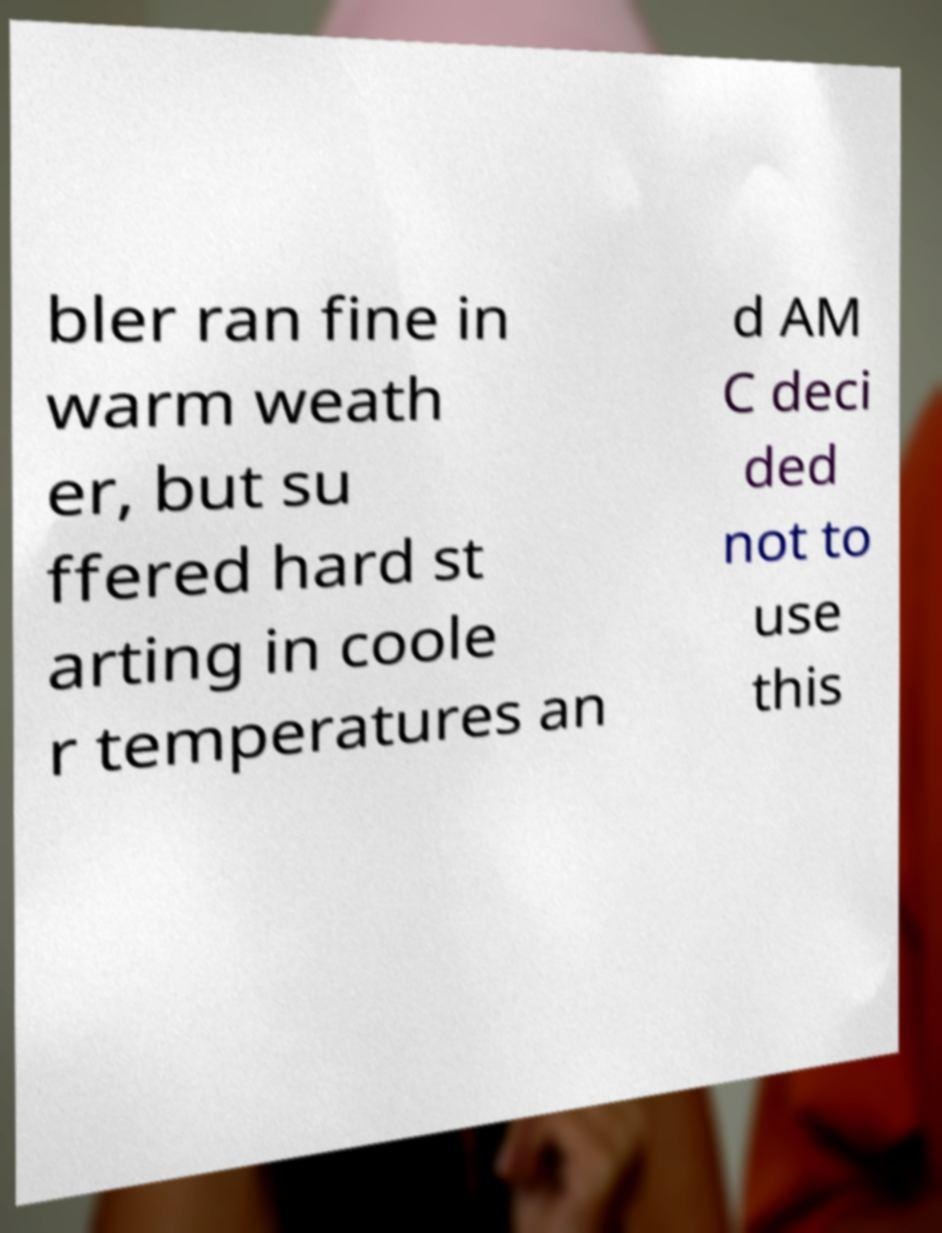Could you extract and type out the text from this image? bler ran fine in warm weath er, but su ffered hard st arting in coole r temperatures an d AM C deci ded not to use this 